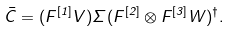<formula> <loc_0><loc_0><loc_500><loc_500>\bar { C } = ( F ^ { [ 1 ] } V ) \Sigma ( F ^ { [ 2 ] } \otimes F ^ { [ 3 ] } W ) ^ { \dagger } .</formula> 